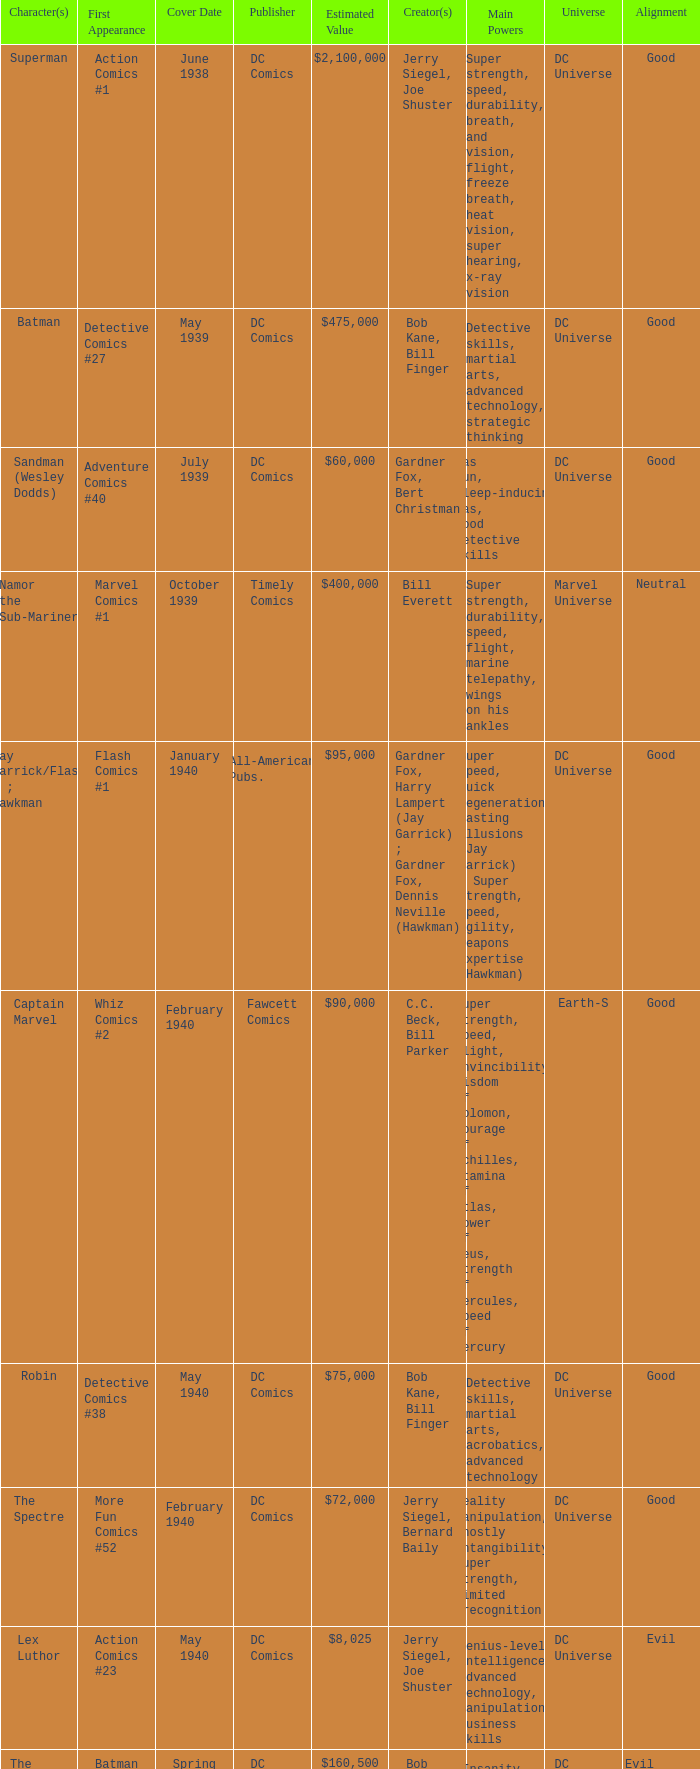Who publishes Wolverine? Marvel Comics. 